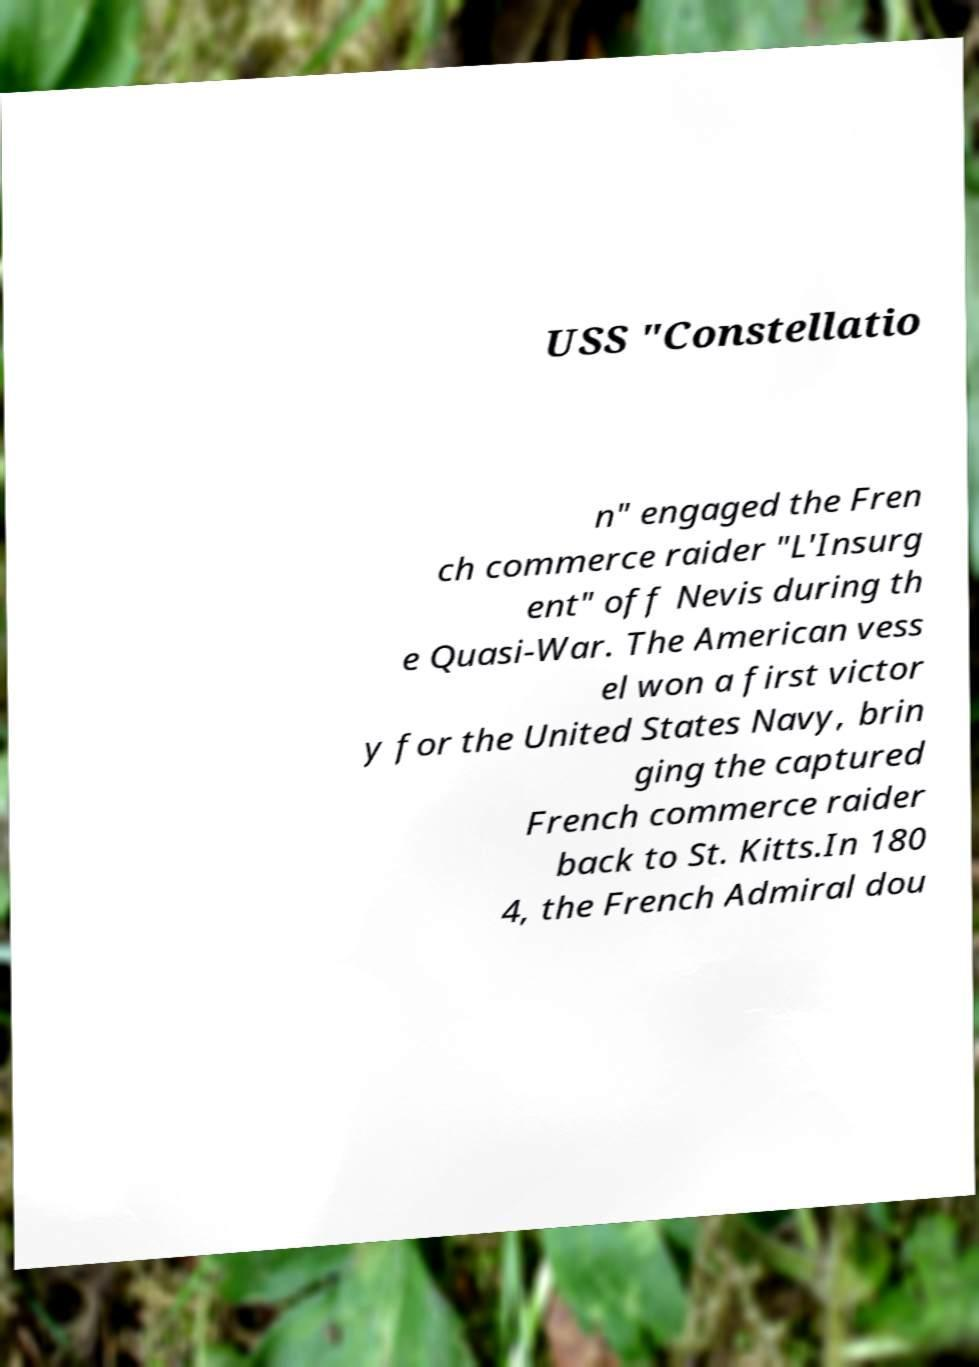Can you accurately transcribe the text from the provided image for me? USS "Constellatio n" engaged the Fren ch commerce raider "L'Insurg ent" off Nevis during th e Quasi-War. The American vess el won a first victor y for the United States Navy, brin ging the captured French commerce raider back to St. Kitts.In 180 4, the French Admiral dou 